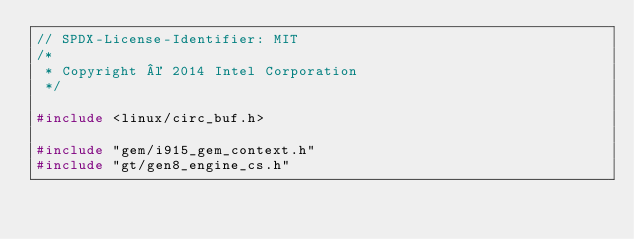Convert code to text. <code><loc_0><loc_0><loc_500><loc_500><_C_>// SPDX-License-Identifier: MIT
/*
 * Copyright © 2014 Intel Corporation
 */

#include <linux/circ_buf.h>

#include "gem/i915_gem_context.h"
#include "gt/gen8_engine_cs.h"</code> 